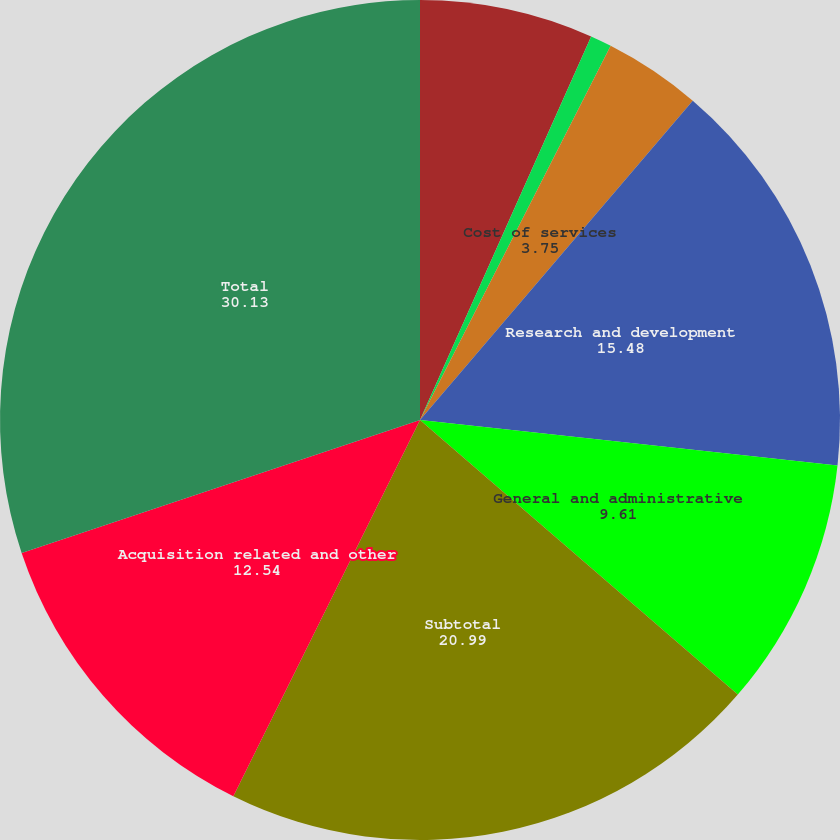<chart> <loc_0><loc_0><loc_500><loc_500><pie_chart><fcel>Sales and marketing<fcel>Software license updates and<fcel>Cost of services<fcel>Research and development<fcel>General and administrative<fcel>Subtotal<fcel>Acquisition related and other<fcel>Total<nl><fcel>6.68%<fcel>0.82%<fcel>3.75%<fcel>15.48%<fcel>9.61%<fcel>20.99%<fcel>12.54%<fcel>30.13%<nl></chart> 